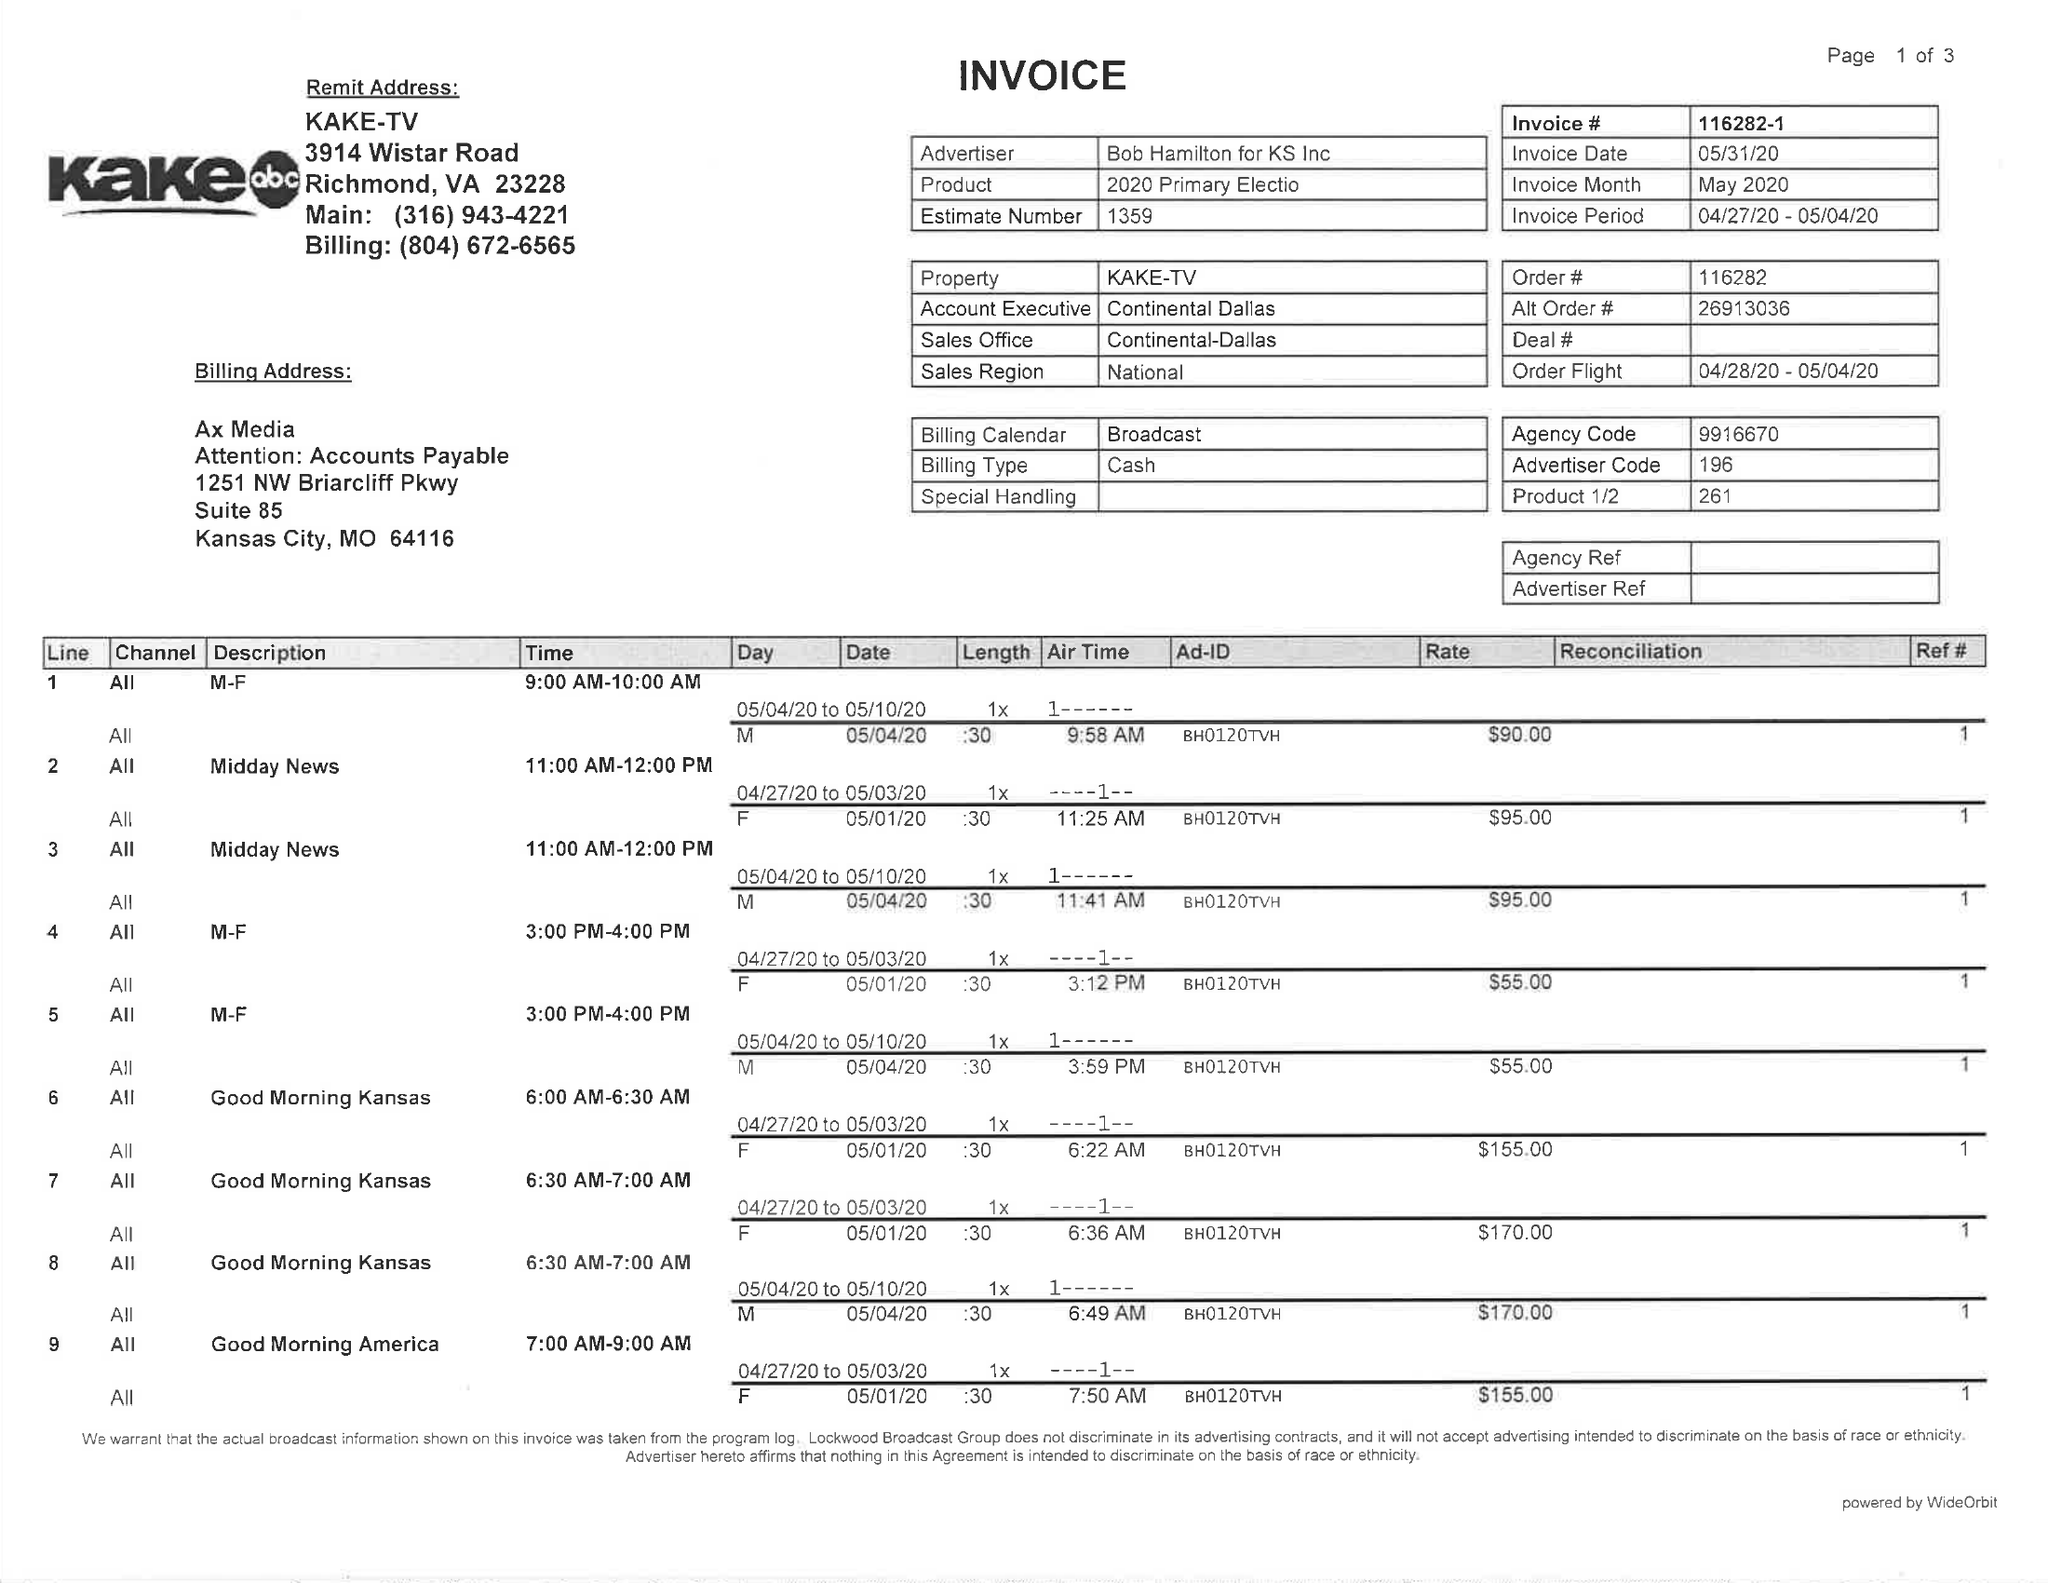What is the value for the advertiser?
Answer the question using a single word or phrase. BOB HAMÌLTON FOR KS LNC 